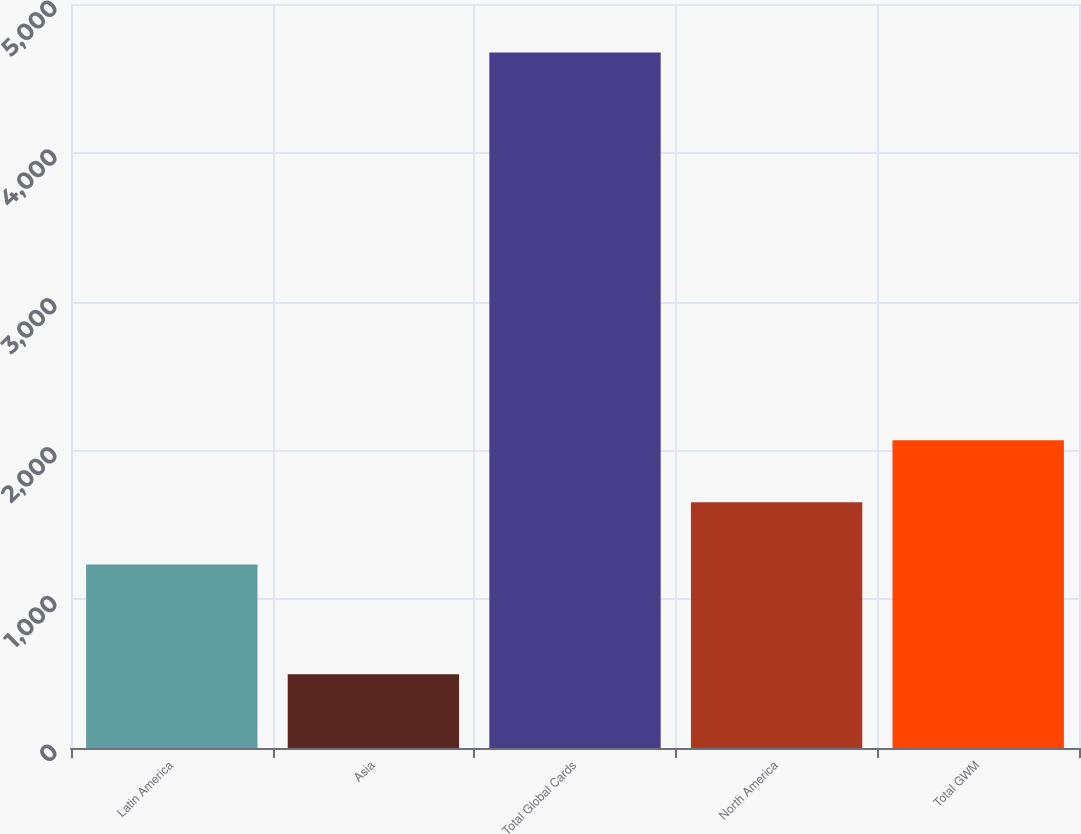Convert chart to OTSL. <chart><loc_0><loc_0><loc_500><loc_500><bar_chart><fcel>Latin America<fcel>Asia<fcel>Total Global Cards<fcel>North America<fcel>Total GWM<nl><fcel>1233<fcel>496<fcel>4674<fcel>1650.8<fcel>2068.6<nl></chart> 